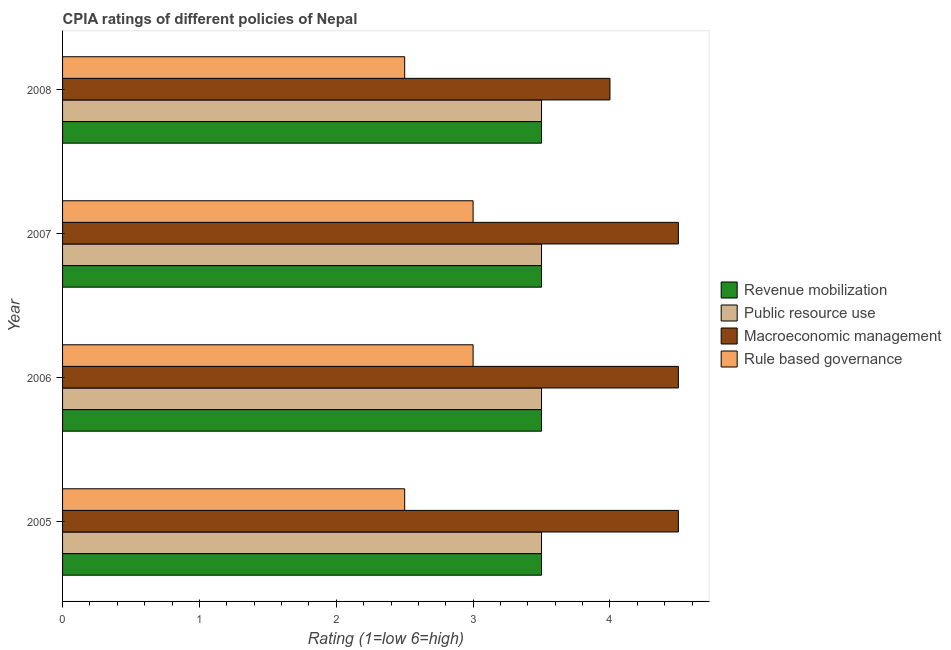How many different coloured bars are there?
Give a very brief answer. 4. How many groups of bars are there?
Your answer should be very brief. 4. Are the number of bars on each tick of the Y-axis equal?
Your response must be concise. Yes. How many bars are there on the 1st tick from the bottom?
Provide a succinct answer. 4. In how many cases, is the number of bars for a given year not equal to the number of legend labels?
Offer a very short reply. 0. What is the cpia rating of public resource use in 2005?
Ensure brevity in your answer.  3.5. Across all years, what is the minimum cpia rating of macroeconomic management?
Make the answer very short. 4. In which year was the cpia rating of rule based governance maximum?
Offer a very short reply. 2006. In which year was the cpia rating of macroeconomic management minimum?
Offer a very short reply. 2008. What is the average cpia rating of macroeconomic management per year?
Make the answer very short. 4.38. In how many years, is the cpia rating of rule based governance greater than 3.6 ?
Offer a terse response. 0. Is the difference between the cpia rating of rule based governance in 2007 and 2008 greater than the difference between the cpia rating of revenue mobilization in 2007 and 2008?
Make the answer very short. Yes. In how many years, is the cpia rating of rule based governance greater than the average cpia rating of rule based governance taken over all years?
Give a very brief answer. 2. What does the 4th bar from the top in 2007 represents?
Give a very brief answer. Revenue mobilization. What does the 1st bar from the bottom in 2007 represents?
Offer a very short reply. Revenue mobilization. Is it the case that in every year, the sum of the cpia rating of revenue mobilization and cpia rating of public resource use is greater than the cpia rating of macroeconomic management?
Make the answer very short. Yes. How many bars are there?
Provide a short and direct response. 16. What is the difference between two consecutive major ticks on the X-axis?
Make the answer very short. 1. Are the values on the major ticks of X-axis written in scientific E-notation?
Offer a terse response. No. Does the graph contain any zero values?
Make the answer very short. No. Where does the legend appear in the graph?
Keep it short and to the point. Center right. How are the legend labels stacked?
Make the answer very short. Vertical. What is the title of the graph?
Give a very brief answer. CPIA ratings of different policies of Nepal. Does "Public sector management" appear as one of the legend labels in the graph?
Ensure brevity in your answer.  No. What is the label or title of the Y-axis?
Provide a succinct answer. Year. What is the Rating (1=low 6=high) in Rule based governance in 2005?
Give a very brief answer. 2.5. What is the Rating (1=low 6=high) in Revenue mobilization in 2006?
Provide a short and direct response. 3.5. What is the Rating (1=low 6=high) in Public resource use in 2007?
Provide a short and direct response. 3.5. What is the Rating (1=low 6=high) of Rule based governance in 2007?
Give a very brief answer. 3. What is the Rating (1=low 6=high) of Revenue mobilization in 2008?
Your answer should be compact. 3.5. What is the Rating (1=low 6=high) in Macroeconomic management in 2008?
Give a very brief answer. 4. Across all years, what is the maximum Rating (1=low 6=high) of Public resource use?
Your response must be concise. 3.5. Across all years, what is the maximum Rating (1=low 6=high) of Macroeconomic management?
Give a very brief answer. 4.5. Across all years, what is the minimum Rating (1=low 6=high) of Revenue mobilization?
Provide a short and direct response. 3.5. Across all years, what is the minimum Rating (1=low 6=high) in Macroeconomic management?
Ensure brevity in your answer.  4. Across all years, what is the minimum Rating (1=low 6=high) in Rule based governance?
Provide a succinct answer. 2.5. What is the total Rating (1=low 6=high) in Revenue mobilization in the graph?
Your response must be concise. 14. What is the total Rating (1=low 6=high) of Public resource use in the graph?
Your answer should be very brief. 14. What is the total Rating (1=low 6=high) in Rule based governance in the graph?
Give a very brief answer. 11. What is the difference between the Rating (1=low 6=high) of Revenue mobilization in 2005 and that in 2006?
Provide a short and direct response. 0. What is the difference between the Rating (1=low 6=high) of Public resource use in 2005 and that in 2006?
Give a very brief answer. 0. What is the difference between the Rating (1=low 6=high) of Macroeconomic management in 2005 and that in 2006?
Make the answer very short. 0. What is the difference between the Rating (1=low 6=high) in Revenue mobilization in 2005 and that in 2007?
Provide a short and direct response. 0. What is the difference between the Rating (1=low 6=high) in Public resource use in 2005 and that in 2007?
Offer a terse response. 0. What is the difference between the Rating (1=low 6=high) in Rule based governance in 2005 and that in 2007?
Your answer should be very brief. -0.5. What is the difference between the Rating (1=low 6=high) in Revenue mobilization in 2005 and that in 2008?
Give a very brief answer. 0. What is the difference between the Rating (1=low 6=high) in Rule based governance in 2005 and that in 2008?
Your answer should be compact. 0. What is the difference between the Rating (1=low 6=high) in Rule based governance in 2006 and that in 2007?
Keep it short and to the point. 0. What is the difference between the Rating (1=low 6=high) in Public resource use in 2006 and that in 2008?
Your answer should be very brief. 0. What is the difference between the Rating (1=low 6=high) in Revenue mobilization in 2007 and that in 2008?
Your answer should be compact. 0. What is the difference between the Rating (1=low 6=high) of Public resource use in 2007 and that in 2008?
Your response must be concise. 0. What is the difference between the Rating (1=low 6=high) in Macroeconomic management in 2007 and that in 2008?
Offer a very short reply. 0.5. What is the difference between the Rating (1=low 6=high) of Rule based governance in 2007 and that in 2008?
Provide a succinct answer. 0.5. What is the difference between the Rating (1=low 6=high) of Public resource use in 2005 and the Rating (1=low 6=high) of Rule based governance in 2006?
Keep it short and to the point. 0.5. What is the difference between the Rating (1=low 6=high) in Macroeconomic management in 2005 and the Rating (1=low 6=high) in Rule based governance in 2006?
Give a very brief answer. 1.5. What is the difference between the Rating (1=low 6=high) in Revenue mobilization in 2005 and the Rating (1=low 6=high) in Rule based governance in 2007?
Offer a terse response. 0.5. What is the difference between the Rating (1=low 6=high) of Public resource use in 2005 and the Rating (1=low 6=high) of Macroeconomic management in 2007?
Offer a very short reply. -1. What is the difference between the Rating (1=low 6=high) in Macroeconomic management in 2005 and the Rating (1=low 6=high) in Rule based governance in 2007?
Your answer should be compact. 1.5. What is the difference between the Rating (1=low 6=high) in Revenue mobilization in 2005 and the Rating (1=low 6=high) in Public resource use in 2008?
Your response must be concise. 0. What is the difference between the Rating (1=low 6=high) in Revenue mobilization in 2005 and the Rating (1=low 6=high) in Macroeconomic management in 2008?
Your response must be concise. -0.5. What is the difference between the Rating (1=low 6=high) of Public resource use in 2005 and the Rating (1=low 6=high) of Rule based governance in 2008?
Provide a succinct answer. 1. What is the difference between the Rating (1=low 6=high) of Macroeconomic management in 2005 and the Rating (1=low 6=high) of Rule based governance in 2008?
Your response must be concise. 2. What is the difference between the Rating (1=low 6=high) in Revenue mobilization in 2006 and the Rating (1=low 6=high) in Macroeconomic management in 2007?
Your answer should be very brief. -1. What is the difference between the Rating (1=low 6=high) in Revenue mobilization in 2006 and the Rating (1=low 6=high) in Rule based governance in 2007?
Ensure brevity in your answer.  0.5. What is the difference between the Rating (1=low 6=high) in Revenue mobilization in 2006 and the Rating (1=low 6=high) in Rule based governance in 2008?
Ensure brevity in your answer.  1. What is the difference between the Rating (1=low 6=high) in Public resource use in 2006 and the Rating (1=low 6=high) in Macroeconomic management in 2008?
Offer a very short reply. -0.5. What is the difference between the Rating (1=low 6=high) in Public resource use in 2006 and the Rating (1=low 6=high) in Rule based governance in 2008?
Ensure brevity in your answer.  1. What is the difference between the Rating (1=low 6=high) of Revenue mobilization in 2007 and the Rating (1=low 6=high) of Macroeconomic management in 2008?
Provide a short and direct response. -0.5. What is the difference between the Rating (1=low 6=high) of Revenue mobilization in 2007 and the Rating (1=low 6=high) of Rule based governance in 2008?
Make the answer very short. 1. What is the difference between the Rating (1=low 6=high) in Public resource use in 2007 and the Rating (1=low 6=high) in Rule based governance in 2008?
Your answer should be compact. 1. What is the average Rating (1=low 6=high) of Revenue mobilization per year?
Offer a terse response. 3.5. What is the average Rating (1=low 6=high) in Macroeconomic management per year?
Keep it short and to the point. 4.38. What is the average Rating (1=low 6=high) of Rule based governance per year?
Offer a very short reply. 2.75. In the year 2005, what is the difference between the Rating (1=low 6=high) of Revenue mobilization and Rating (1=low 6=high) of Public resource use?
Your answer should be compact. 0. In the year 2005, what is the difference between the Rating (1=low 6=high) in Revenue mobilization and Rating (1=low 6=high) in Macroeconomic management?
Offer a very short reply. -1. In the year 2005, what is the difference between the Rating (1=low 6=high) in Revenue mobilization and Rating (1=low 6=high) in Rule based governance?
Offer a terse response. 1. In the year 2005, what is the difference between the Rating (1=low 6=high) in Public resource use and Rating (1=low 6=high) in Macroeconomic management?
Ensure brevity in your answer.  -1. In the year 2005, what is the difference between the Rating (1=low 6=high) of Macroeconomic management and Rating (1=low 6=high) of Rule based governance?
Keep it short and to the point. 2. In the year 2006, what is the difference between the Rating (1=low 6=high) in Revenue mobilization and Rating (1=low 6=high) in Rule based governance?
Provide a short and direct response. 0.5. In the year 2006, what is the difference between the Rating (1=low 6=high) of Public resource use and Rating (1=low 6=high) of Macroeconomic management?
Your response must be concise. -1. In the year 2007, what is the difference between the Rating (1=low 6=high) in Revenue mobilization and Rating (1=low 6=high) in Public resource use?
Give a very brief answer. 0. In the year 2007, what is the difference between the Rating (1=low 6=high) in Revenue mobilization and Rating (1=low 6=high) in Macroeconomic management?
Provide a short and direct response. -1. In the year 2007, what is the difference between the Rating (1=low 6=high) in Public resource use and Rating (1=low 6=high) in Macroeconomic management?
Provide a short and direct response. -1. In the year 2007, what is the difference between the Rating (1=low 6=high) of Public resource use and Rating (1=low 6=high) of Rule based governance?
Offer a very short reply. 0.5. In the year 2008, what is the difference between the Rating (1=low 6=high) of Revenue mobilization and Rating (1=low 6=high) of Rule based governance?
Provide a succinct answer. 1. In the year 2008, what is the difference between the Rating (1=low 6=high) in Public resource use and Rating (1=low 6=high) in Rule based governance?
Ensure brevity in your answer.  1. What is the ratio of the Rating (1=low 6=high) of Revenue mobilization in 2005 to that in 2006?
Make the answer very short. 1. What is the ratio of the Rating (1=low 6=high) in Public resource use in 2005 to that in 2006?
Your response must be concise. 1. What is the ratio of the Rating (1=low 6=high) of Public resource use in 2005 to that in 2007?
Offer a very short reply. 1. What is the ratio of the Rating (1=low 6=high) of Macroeconomic management in 2005 to that in 2007?
Offer a very short reply. 1. What is the ratio of the Rating (1=low 6=high) of Revenue mobilization in 2005 to that in 2008?
Offer a very short reply. 1. What is the ratio of the Rating (1=low 6=high) of Public resource use in 2005 to that in 2008?
Offer a very short reply. 1. What is the ratio of the Rating (1=low 6=high) of Macroeconomic management in 2005 to that in 2008?
Ensure brevity in your answer.  1.12. What is the ratio of the Rating (1=low 6=high) of Revenue mobilization in 2006 to that in 2007?
Keep it short and to the point. 1. What is the ratio of the Rating (1=low 6=high) of Rule based governance in 2006 to that in 2007?
Provide a short and direct response. 1. What is the ratio of the Rating (1=low 6=high) of Revenue mobilization in 2006 to that in 2008?
Provide a succinct answer. 1. What is the ratio of the Rating (1=low 6=high) in Rule based governance in 2006 to that in 2008?
Your answer should be very brief. 1.2. What is the ratio of the Rating (1=low 6=high) in Macroeconomic management in 2007 to that in 2008?
Provide a short and direct response. 1.12. What is the ratio of the Rating (1=low 6=high) of Rule based governance in 2007 to that in 2008?
Offer a terse response. 1.2. What is the difference between the highest and the second highest Rating (1=low 6=high) of Macroeconomic management?
Offer a terse response. 0. What is the difference between the highest and the lowest Rating (1=low 6=high) of Rule based governance?
Give a very brief answer. 0.5. 